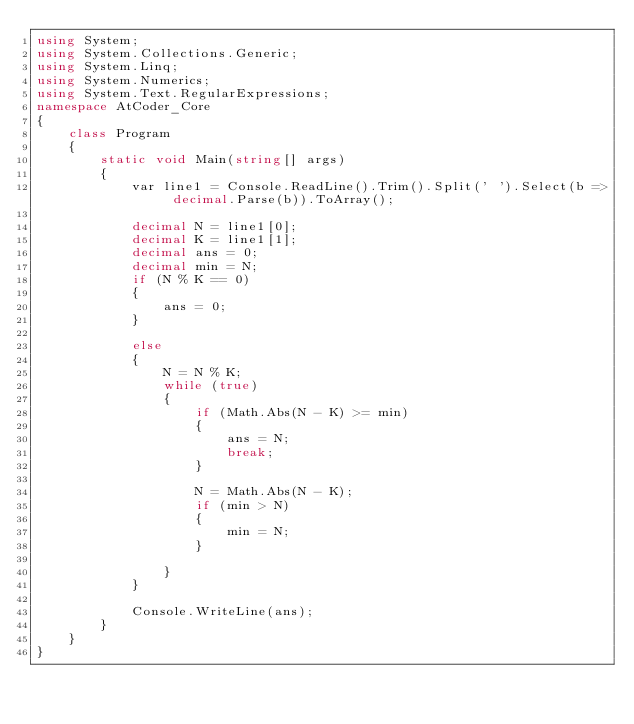Convert code to text. <code><loc_0><loc_0><loc_500><loc_500><_C#_>using System;
using System.Collections.Generic;
using System.Linq;
using System.Numerics;
using System.Text.RegularExpressions;
namespace AtCoder_Core
{
    class Program
    {
        static void Main(string[] args)
        {
            var line1 = Console.ReadLine().Trim().Split(' ').Select(b => decimal.Parse(b)).ToArray();

            decimal N = line1[0];
            decimal K = line1[1];
            decimal ans = 0;
            decimal min = N;
            if (N % K == 0)
            {
                ans = 0;
            }

            else
            {
                N = N % K;
                while (true)
                {
                    if (Math.Abs(N - K) >= min)
                    {
                        ans = N;
                        break;
                    }

                    N = Math.Abs(N - K);
                    if (min > N)
                    {
                        min = N;
                    }

                }
            }

            Console.WriteLine(ans);
        }
    }
}
</code> 